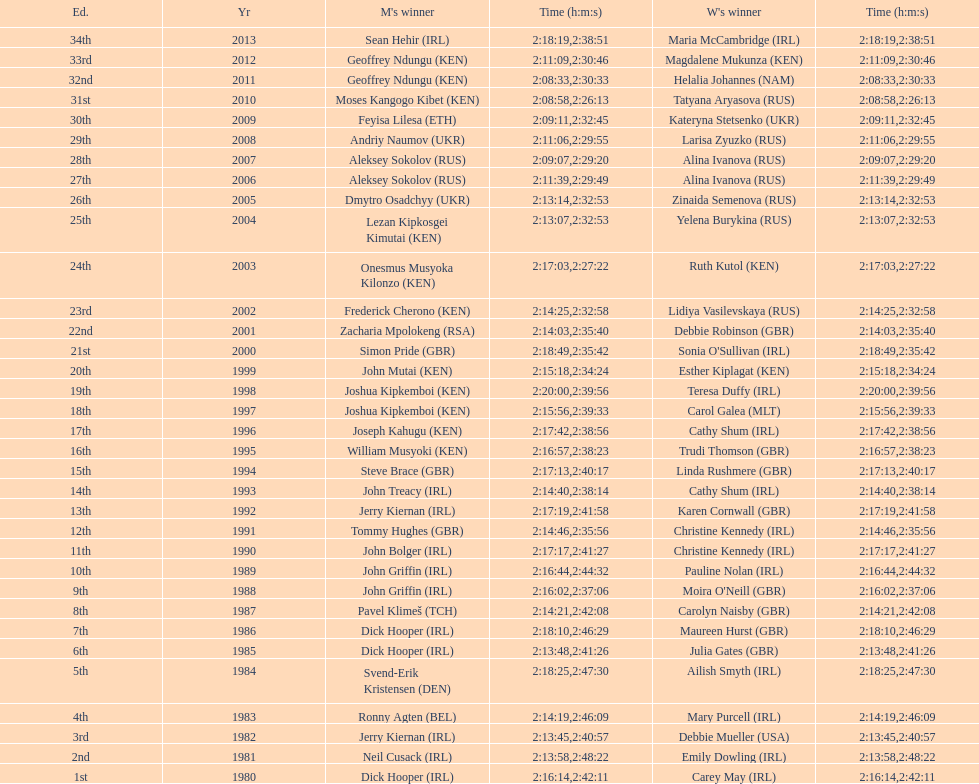In which country are both men and women featured at the highest position on the list? Ireland. 